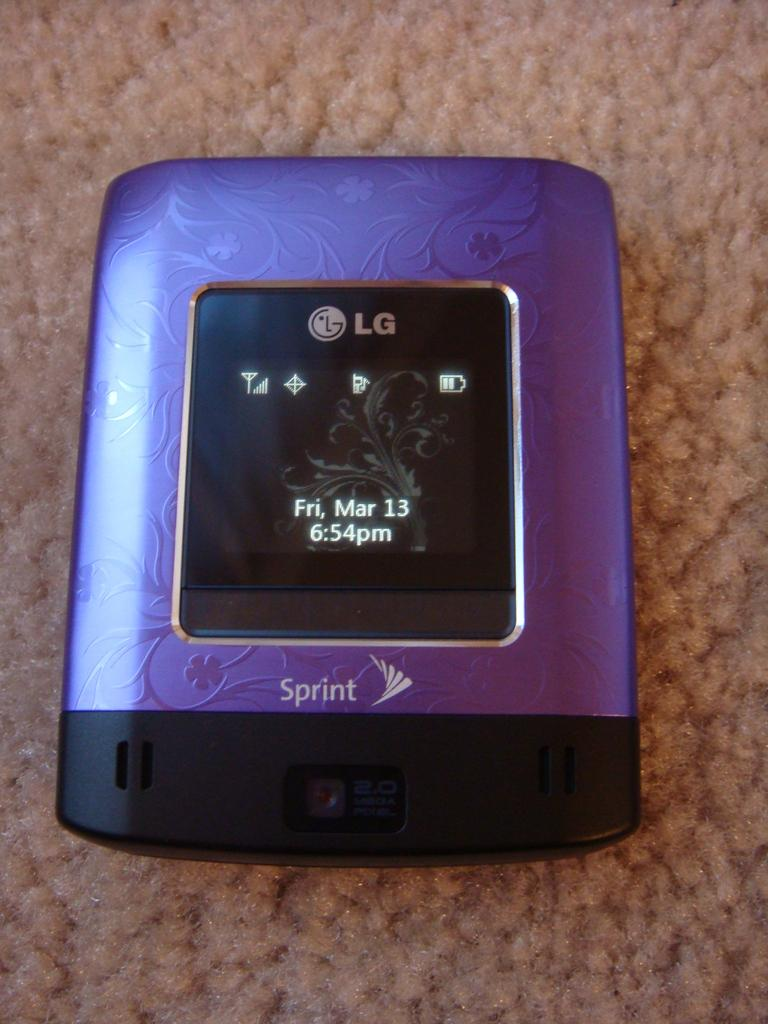<image>
Relay a brief, clear account of the picture shown. an item that has the letters LG on it 